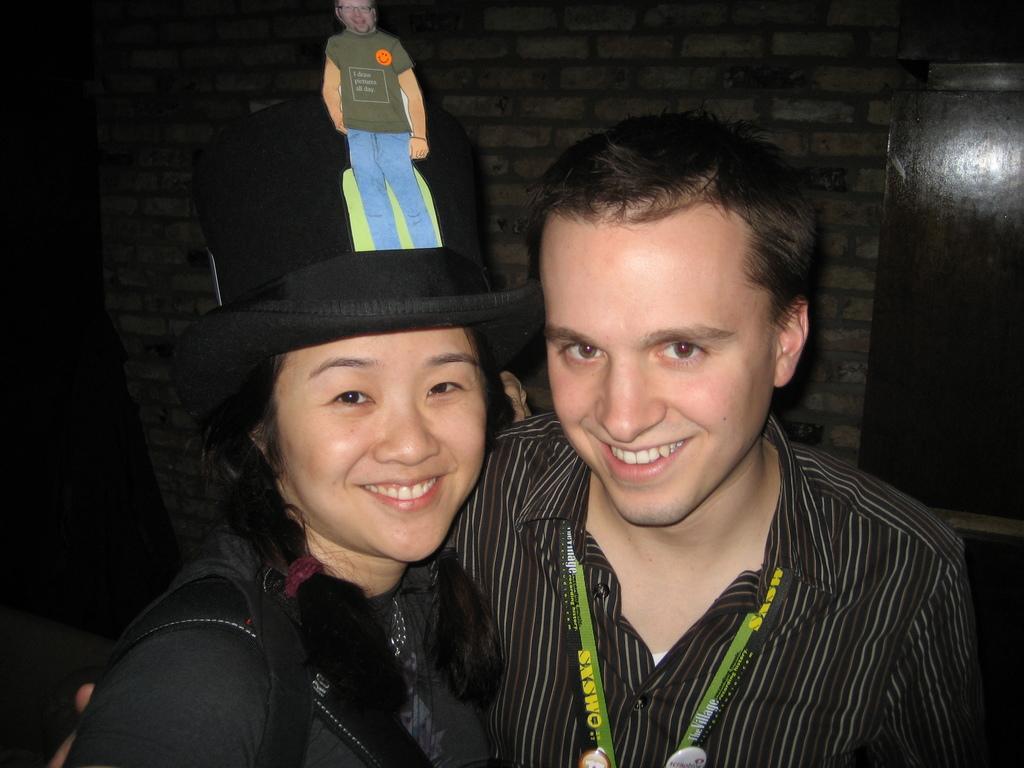How would you summarize this image in a sentence or two? In the foreground of this image, there is a couple standing and the woman is wearing a bag and the hat. They are having smile on their faces. In the background, there is a wall and an object on the right. 